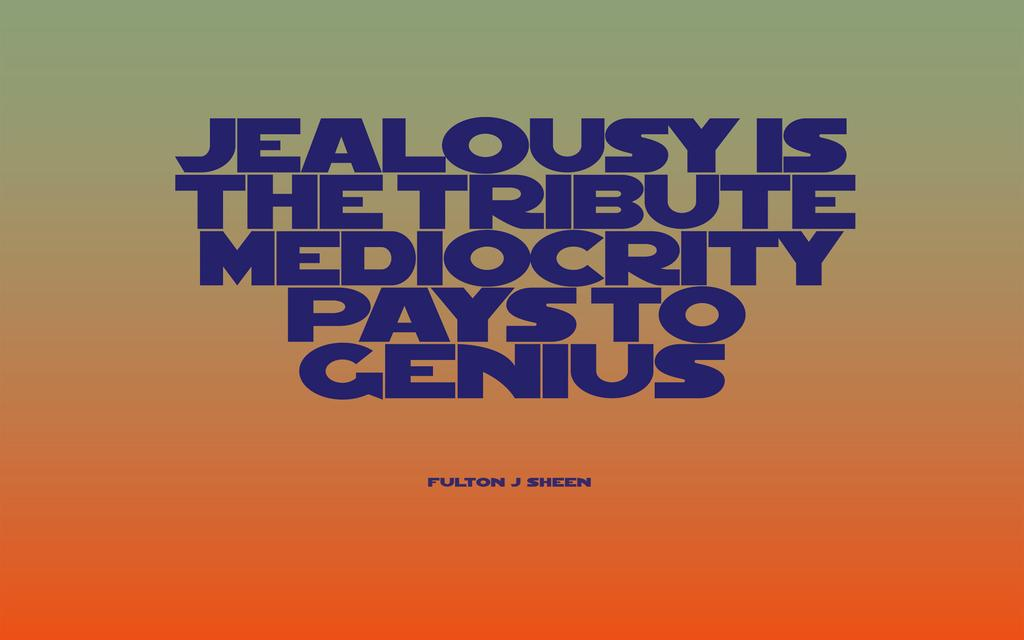<image>
Relay a brief, clear account of the picture shown. Fulton J Sheen has the quote jealousy is the tribute mediocrity pays to genius 